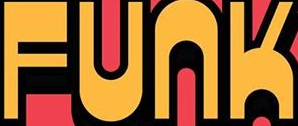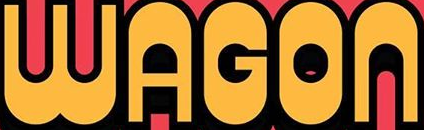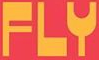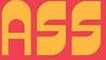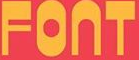What text appears in these images from left to right, separated by a semicolon? FUNK; WAGON; FLY; ASS; FONT 